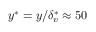Convert formula to latex. <formula><loc_0><loc_0><loc_500><loc_500>y ^ { * } = y / \delta _ { v } ^ { * } \approx 5 0</formula> 